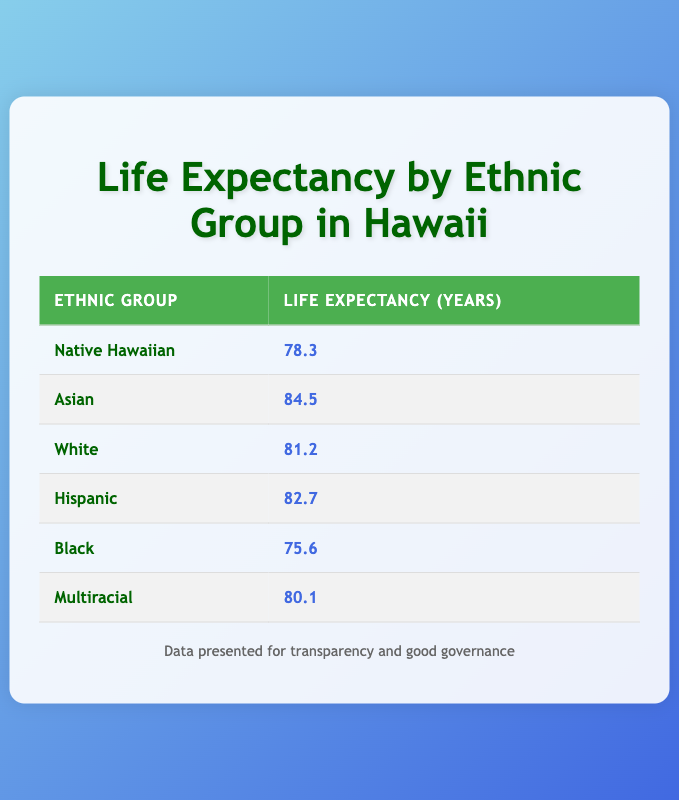What is the life expectancy of Native Hawaiians? The table shows the life expectancy for Native Hawaiians listed under the "Life Expectancy (Years)" column, which is 78.3.
Answer: 78.3 Which ethnic group has the highest life expectancy? By scanning the "Life Expectancy (Years)" column, the highest value is found for the Asian ethnic group at 84.5.
Answer: Asian Is the life expectancy of Hispanics greater than that of Native Hawaiians? Comparing the life expectancy, Hispanics have 82.7 while Native Hawaiians have 78.3. Since 82.7 is greater than 78.3, the statement is true.
Answer: Yes What is the difference in life expectancy between Whites and Blacks? The life expectancy for Whites is 81.2 and for Blacks is 75.6. To find the difference, we subtract 75.6 from 81.2, yielding 5.6.
Answer: 5.6 Calculate the average life expectancy of Multiracial and Native Hawaiian groups. The life expectancy for Multiracial is 80.1 and for Native Hawaiian is 78.3. To get the average, first sum these two values: 80.1 + 78.3 = 158.4, then divide by 2: 158.4/2 = 79.2.
Answer: 79.2 Does the table indicate that the life expectancy for Native Hawaiians is above 80 years? The life expectancy for Native Hawaiians is listed as 78.3, which is below 80 years, thus the statement is false.
Answer: No What is the combined life expectancy of all ethnic groups listed? To find the combined life expectancy, we sum the individual life expectancies: 78.3 + 84.5 + 81.2 + 82.7 + 75.6 + 80.1 = 482.4. Thus, the combined life expectancy is 482.4.
Answer: 482.4 Are there more ethnic groups with a life expectancy above 80 years than below? Reviewing the table, the ethnic groups with a life expectancy above 80 are Asian (84.5), White (81.2), and Hispanic (82.7), totaling 3. The groups below 80 are Native Hawaiian (78.3), Black (75.6), and this totals 2 groups. Therefore, there are more groups above 80 years.
Answer: Yes What is the median life expectancy of the ethnic groups listed? To find the median, we first list the life expectancies in order: 75.6, 78.3, 80.1, 81.2, 82.7, 84.5 (6 values). The median will be the average of the 3rd and 4th values: (80.1 + 81.2)/2 = 80.65. Thus, the median life expectancy is 80.65.
Answer: 80.65 